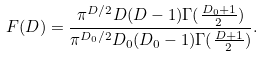<formula> <loc_0><loc_0><loc_500><loc_500>F ( D ) = \frac { \pi ^ { D / 2 } D ( D - 1 ) \Gamma ( \frac { D _ { 0 } + 1 } { 2 } ) } { \pi ^ { { D _ { 0 } } / 2 } D _ { 0 } ( D _ { 0 } - 1 ) \Gamma ( \frac { D + 1 } { 2 } ) } .</formula> 